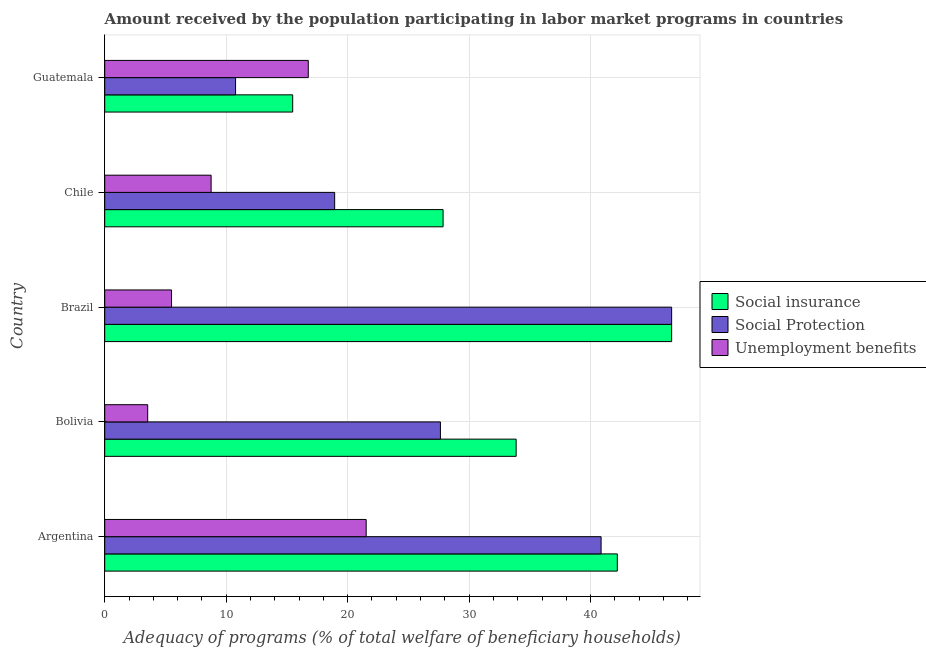How many different coloured bars are there?
Give a very brief answer. 3. Are the number of bars on each tick of the Y-axis equal?
Offer a very short reply. Yes. How many bars are there on the 5th tick from the top?
Give a very brief answer. 3. What is the label of the 4th group of bars from the top?
Provide a short and direct response. Bolivia. What is the amount received by the population participating in social insurance programs in Brazil?
Your answer should be very brief. 46.67. Across all countries, what is the maximum amount received by the population participating in social protection programs?
Offer a terse response. 46.67. Across all countries, what is the minimum amount received by the population participating in unemployment benefits programs?
Your response must be concise. 3.54. In which country was the amount received by the population participating in social protection programs minimum?
Provide a short and direct response. Guatemala. What is the total amount received by the population participating in social insurance programs in the graph?
Make the answer very short. 166.06. What is the difference between the amount received by the population participating in social insurance programs in Brazil and that in Chile?
Keep it short and to the point. 18.81. What is the difference between the amount received by the population participating in social insurance programs in Argentina and the amount received by the population participating in unemployment benefits programs in Bolivia?
Your answer should be compact. 38.66. What is the average amount received by the population participating in social insurance programs per country?
Ensure brevity in your answer.  33.21. What is the difference between the amount received by the population participating in social protection programs and amount received by the population participating in social insurance programs in Bolivia?
Give a very brief answer. -6.23. What is the ratio of the amount received by the population participating in unemployment benefits programs in Argentina to that in Chile?
Your answer should be compact. 2.46. Is the amount received by the population participating in social protection programs in Bolivia less than that in Guatemala?
Provide a short and direct response. No. Is the difference between the amount received by the population participating in social insurance programs in Bolivia and Brazil greater than the difference between the amount received by the population participating in unemployment benefits programs in Bolivia and Brazil?
Keep it short and to the point. No. What is the difference between the highest and the second highest amount received by the population participating in social protection programs?
Offer a terse response. 5.81. What is the difference between the highest and the lowest amount received by the population participating in social protection programs?
Offer a terse response. 35.9. In how many countries, is the amount received by the population participating in social insurance programs greater than the average amount received by the population participating in social insurance programs taken over all countries?
Provide a short and direct response. 3. Is the sum of the amount received by the population participating in social insurance programs in Argentina and Bolivia greater than the maximum amount received by the population participating in unemployment benefits programs across all countries?
Keep it short and to the point. Yes. What does the 2nd bar from the top in Chile represents?
Your response must be concise. Social Protection. What does the 2nd bar from the bottom in Bolivia represents?
Your answer should be very brief. Social Protection. Is it the case that in every country, the sum of the amount received by the population participating in social insurance programs and amount received by the population participating in social protection programs is greater than the amount received by the population participating in unemployment benefits programs?
Offer a terse response. Yes. What is the difference between two consecutive major ticks on the X-axis?
Your answer should be very brief. 10. Are the values on the major ticks of X-axis written in scientific E-notation?
Make the answer very short. No. How many legend labels are there?
Your answer should be very brief. 3. How are the legend labels stacked?
Give a very brief answer. Vertical. What is the title of the graph?
Provide a short and direct response. Amount received by the population participating in labor market programs in countries. What is the label or title of the X-axis?
Provide a succinct answer. Adequacy of programs (% of total welfare of beneficiary households). What is the Adequacy of programs (% of total welfare of beneficiary households) of Social insurance in Argentina?
Your response must be concise. 42.2. What is the Adequacy of programs (% of total welfare of beneficiary households) in Social Protection in Argentina?
Provide a short and direct response. 40.86. What is the Adequacy of programs (% of total welfare of beneficiary households) of Unemployment benefits in Argentina?
Offer a terse response. 21.52. What is the Adequacy of programs (% of total welfare of beneficiary households) of Social insurance in Bolivia?
Your answer should be compact. 33.87. What is the Adequacy of programs (% of total welfare of beneficiary households) in Social Protection in Bolivia?
Ensure brevity in your answer.  27.63. What is the Adequacy of programs (% of total welfare of beneficiary households) of Unemployment benefits in Bolivia?
Offer a terse response. 3.54. What is the Adequacy of programs (% of total welfare of beneficiary households) in Social insurance in Brazil?
Provide a succinct answer. 46.67. What is the Adequacy of programs (% of total welfare of beneficiary households) of Social Protection in Brazil?
Offer a very short reply. 46.67. What is the Adequacy of programs (% of total welfare of beneficiary households) of Unemployment benefits in Brazil?
Your answer should be compact. 5.5. What is the Adequacy of programs (% of total welfare of beneficiary households) in Social insurance in Chile?
Offer a terse response. 27.85. What is the Adequacy of programs (% of total welfare of beneficiary households) in Social Protection in Chile?
Provide a short and direct response. 18.93. What is the Adequacy of programs (% of total welfare of beneficiary households) of Unemployment benefits in Chile?
Make the answer very short. 8.76. What is the Adequacy of programs (% of total welfare of beneficiary households) in Social insurance in Guatemala?
Give a very brief answer. 15.47. What is the Adequacy of programs (% of total welfare of beneficiary households) of Social Protection in Guatemala?
Your response must be concise. 10.77. What is the Adequacy of programs (% of total welfare of beneficiary households) of Unemployment benefits in Guatemala?
Your response must be concise. 16.76. Across all countries, what is the maximum Adequacy of programs (% of total welfare of beneficiary households) of Social insurance?
Your answer should be very brief. 46.67. Across all countries, what is the maximum Adequacy of programs (% of total welfare of beneficiary households) in Social Protection?
Your response must be concise. 46.67. Across all countries, what is the maximum Adequacy of programs (% of total welfare of beneficiary households) of Unemployment benefits?
Keep it short and to the point. 21.52. Across all countries, what is the minimum Adequacy of programs (% of total welfare of beneficiary households) in Social insurance?
Ensure brevity in your answer.  15.47. Across all countries, what is the minimum Adequacy of programs (% of total welfare of beneficiary households) of Social Protection?
Your answer should be very brief. 10.77. Across all countries, what is the minimum Adequacy of programs (% of total welfare of beneficiary households) in Unemployment benefits?
Keep it short and to the point. 3.54. What is the total Adequacy of programs (% of total welfare of beneficiary households) of Social insurance in the graph?
Offer a very short reply. 166.06. What is the total Adequacy of programs (% of total welfare of beneficiary households) in Social Protection in the graph?
Your response must be concise. 144.86. What is the total Adequacy of programs (% of total welfare of beneficiary households) of Unemployment benefits in the graph?
Offer a terse response. 56.07. What is the difference between the Adequacy of programs (% of total welfare of beneficiary households) in Social insurance in Argentina and that in Bolivia?
Offer a very short reply. 8.33. What is the difference between the Adequacy of programs (% of total welfare of beneficiary households) in Social Protection in Argentina and that in Bolivia?
Your response must be concise. 13.23. What is the difference between the Adequacy of programs (% of total welfare of beneficiary households) of Unemployment benefits in Argentina and that in Bolivia?
Ensure brevity in your answer.  17.98. What is the difference between the Adequacy of programs (% of total welfare of beneficiary households) in Social insurance in Argentina and that in Brazil?
Keep it short and to the point. -4.47. What is the difference between the Adequacy of programs (% of total welfare of beneficiary households) in Social Protection in Argentina and that in Brazil?
Keep it short and to the point. -5.81. What is the difference between the Adequacy of programs (% of total welfare of beneficiary households) in Unemployment benefits in Argentina and that in Brazil?
Ensure brevity in your answer.  16.02. What is the difference between the Adequacy of programs (% of total welfare of beneficiary households) of Social insurance in Argentina and that in Chile?
Your answer should be very brief. 14.34. What is the difference between the Adequacy of programs (% of total welfare of beneficiary households) in Social Protection in Argentina and that in Chile?
Your answer should be compact. 21.93. What is the difference between the Adequacy of programs (% of total welfare of beneficiary households) in Unemployment benefits in Argentina and that in Chile?
Ensure brevity in your answer.  12.76. What is the difference between the Adequacy of programs (% of total welfare of beneficiary households) in Social insurance in Argentina and that in Guatemala?
Offer a terse response. 26.72. What is the difference between the Adequacy of programs (% of total welfare of beneficiary households) of Social Protection in Argentina and that in Guatemala?
Offer a terse response. 30.09. What is the difference between the Adequacy of programs (% of total welfare of beneficiary households) of Unemployment benefits in Argentina and that in Guatemala?
Your answer should be very brief. 4.76. What is the difference between the Adequacy of programs (% of total welfare of beneficiary households) of Social Protection in Bolivia and that in Brazil?
Your answer should be compact. -19.03. What is the difference between the Adequacy of programs (% of total welfare of beneficiary households) in Unemployment benefits in Bolivia and that in Brazil?
Give a very brief answer. -1.96. What is the difference between the Adequacy of programs (% of total welfare of beneficiary households) in Social insurance in Bolivia and that in Chile?
Keep it short and to the point. 6.01. What is the difference between the Adequacy of programs (% of total welfare of beneficiary households) of Social Protection in Bolivia and that in Chile?
Offer a very short reply. 8.71. What is the difference between the Adequacy of programs (% of total welfare of beneficiary households) in Unemployment benefits in Bolivia and that in Chile?
Your answer should be compact. -5.22. What is the difference between the Adequacy of programs (% of total welfare of beneficiary households) in Social insurance in Bolivia and that in Guatemala?
Your answer should be compact. 18.39. What is the difference between the Adequacy of programs (% of total welfare of beneficiary households) in Social Protection in Bolivia and that in Guatemala?
Your answer should be very brief. 16.86. What is the difference between the Adequacy of programs (% of total welfare of beneficiary households) of Unemployment benefits in Bolivia and that in Guatemala?
Ensure brevity in your answer.  -13.22. What is the difference between the Adequacy of programs (% of total welfare of beneficiary households) of Social insurance in Brazil and that in Chile?
Your answer should be very brief. 18.81. What is the difference between the Adequacy of programs (% of total welfare of beneficiary households) in Social Protection in Brazil and that in Chile?
Make the answer very short. 27.74. What is the difference between the Adequacy of programs (% of total welfare of beneficiary households) of Unemployment benefits in Brazil and that in Chile?
Provide a short and direct response. -3.26. What is the difference between the Adequacy of programs (% of total welfare of beneficiary households) of Social insurance in Brazil and that in Guatemala?
Give a very brief answer. 31.19. What is the difference between the Adequacy of programs (% of total welfare of beneficiary households) of Social Protection in Brazil and that in Guatemala?
Make the answer very short. 35.9. What is the difference between the Adequacy of programs (% of total welfare of beneficiary households) in Unemployment benefits in Brazil and that in Guatemala?
Keep it short and to the point. -11.26. What is the difference between the Adequacy of programs (% of total welfare of beneficiary households) in Social insurance in Chile and that in Guatemala?
Your answer should be compact. 12.38. What is the difference between the Adequacy of programs (% of total welfare of beneficiary households) of Social Protection in Chile and that in Guatemala?
Ensure brevity in your answer.  8.16. What is the difference between the Adequacy of programs (% of total welfare of beneficiary households) in Unemployment benefits in Chile and that in Guatemala?
Offer a very short reply. -8. What is the difference between the Adequacy of programs (% of total welfare of beneficiary households) in Social insurance in Argentina and the Adequacy of programs (% of total welfare of beneficiary households) in Social Protection in Bolivia?
Give a very brief answer. 14.56. What is the difference between the Adequacy of programs (% of total welfare of beneficiary households) in Social insurance in Argentina and the Adequacy of programs (% of total welfare of beneficiary households) in Unemployment benefits in Bolivia?
Provide a succinct answer. 38.66. What is the difference between the Adequacy of programs (% of total welfare of beneficiary households) in Social Protection in Argentina and the Adequacy of programs (% of total welfare of beneficiary households) in Unemployment benefits in Bolivia?
Make the answer very short. 37.32. What is the difference between the Adequacy of programs (% of total welfare of beneficiary households) in Social insurance in Argentina and the Adequacy of programs (% of total welfare of beneficiary households) in Social Protection in Brazil?
Ensure brevity in your answer.  -4.47. What is the difference between the Adequacy of programs (% of total welfare of beneficiary households) in Social insurance in Argentina and the Adequacy of programs (% of total welfare of beneficiary households) in Unemployment benefits in Brazil?
Provide a short and direct response. 36.69. What is the difference between the Adequacy of programs (% of total welfare of beneficiary households) of Social Protection in Argentina and the Adequacy of programs (% of total welfare of beneficiary households) of Unemployment benefits in Brazil?
Keep it short and to the point. 35.36. What is the difference between the Adequacy of programs (% of total welfare of beneficiary households) of Social insurance in Argentina and the Adequacy of programs (% of total welfare of beneficiary households) of Social Protection in Chile?
Your response must be concise. 23.27. What is the difference between the Adequacy of programs (% of total welfare of beneficiary households) in Social insurance in Argentina and the Adequacy of programs (% of total welfare of beneficiary households) in Unemployment benefits in Chile?
Offer a terse response. 33.44. What is the difference between the Adequacy of programs (% of total welfare of beneficiary households) of Social Protection in Argentina and the Adequacy of programs (% of total welfare of beneficiary households) of Unemployment benefits in Chile?
Your response must be concise. 32.1. What is the difference between the Adequacy of programs (% of total welfare of beneficiary households) in Social insurance in Argentina and the Adequacy of programs (% of total welfare of beneficiary households) in Social Protection in Guatemala?
Provide a short and direct response. 31.42. What is the difference between the Adequacy of programs (% of total welfare of beneficiary households) in Social insurance in Argentina and the Adequacy of programs (% of total welfare of beneficiary households) in Unemployment benefits in Guatemala?
Offer a terse response. 25.44. What is the difference between the Adequacy of programs (% of total welfare of beneficiary households) in Social Protection in Argentina and the Adequacy of programs (% of total welfare of beneficiary households) in Unemployment benefits in Guatemala?
Provide a short and direct response. 24.1. What is the difference between the Adequacy of programs (% of total welfare of beneficiary households) in Social insurance in Bolivia and the Adequacy of programs (% of total welfare of beneficiary households) in Unemployment benefits in Brazil?
Offer a terse response. 28.37. What is the difference between the Adequacy of programs (% of total welfare of beneficiary households) of Social Protection in Bolivia and the Adequacy of programs (% of total welfare of beneficiary households) of Unemployment benefits in Brazil?
Offer a very short reply. 22.13. What is the difference between the Adequacy of programs (% of total welfare of beneficiary households) in Social insurance in Bolivia and the Adequacy of programs (% of total welfare of beneficiary households) in Social Protection in Chile?
Make the answer very short. 14.94. What is the difference between the Adequacy of programs (% of total welfare of beneficiary households) in Social insurance in Bolivia and the Adequacy of programs (% of total welfare of beneficiary households) in Unemployment benefits in Chile?
Offer a very short reply. 25.11. What is the difference between the Adequacy of programs (% of total welfare of beneficiary households) in Social Protection in Bolivia and the Adequacy of programs (% of total welfare of beneficiary households) in Unemployment benefits in Chile?
Give a very brief answer. 18.88. What is the difference between the Adequacy of programs (% of total welfare of beneficiary households) in Social insurance in Bolivia and the Adequacy of programs (% of total welfare of beneficiary households) in Social Protection in Guatemala?
Offer a very short reply. 23.1. What is the difference between the Adequacy of programs (% of total welfare of beneficiary households) of Social insurance in Bolivia and the Adequacy of programs (% of total welfare of beneficiary households) of Unemployment benefits in Guatemala?
Provide a short and direct response. 17.11. What is the difference between the Adequacy of programs (% of total welfare of beneficiary households) of Social Protection in Bolivia and the Adequacy of programs (% of total welfare of beneficiary households) of Unemployment benefits in Guatemala?
Your answer should be very brief. 10.88. What is the difference between the Adequacy of programs (% of total welfare of beneficiary households) in Social insurance in Brazil and the Adequacy of programs (% of total welfare of beneficiary households) in Social Protection in Chile?
Your answer should be compact. 27.74. What is the difference between the Adequacy of programs (% of total welfare of beneficiary households) in Social insurance in Brazil and the Adequacy of programs (% of total welfare of beneficiary households) in Unemployment benefits in Chile?
Offer a very short reply. 37.91. What is the difference between the Adequacy of programs (% of total welfare of beneficiary households) in Social Protection in Brazil and the Adequacy of programs (% of total welfare of beneficiary households) in Unemployment benefits in Chile?
Offer a very short reply. 37.91. What is the difference between the Adequacy of programs (% of total welfare of beneficiary households) in Social insurance in Brazil and the Adequacy of programs (% of total welfare of beneficiary households) in Social Protection in Guatemala?
Provide a succinct answer. 35.9. What is the difference between the Adequacy of programs (% of total welfare of beneficiary households) in Social insurance in Brazil and the Adequacy of programs (% of total welfare of beneficiary households) in Unemployment benefits in Guatemala?
Your answer should be very brief. 29.91. What is the difference between the Adequacy of programs (% of total welfare of beneficiary households) in Social Protection in Brazil and the Adequacy of programs (% of total welfare of beneficiary households) in Unemployment benefits in Guatemala?
Make the answer very short. 29.91. What is the difference between the Adequacy of programs (% of total welfare of beneficiary households) of Social insurance in Chile and the Adequacy of programs (% of total welfare of beneficiary households) of Social Protection in Guatemala?
Provide a succinct answer. 17.08. What is the difference between the Adequacy of programs (% of total welfare of beneficiary households) of Social insurance in Chile and the Adequacy of programs (% of total welfare of beneficiary households) of Unemployment benefits in Guatemala?
Give a very brief answer. 11.1. What is the difference between the Adequacy of programs (% of total welfare of beneficiary households) in Social Protection in Chile and the Adequacy of programs (% of total welfare of beneficiary households) in Unemployment benefits in Guatemala?
Your answer should be compact. 2.17. What is the average Adequacy of programs (% of total welfare of beneficiary households) in Social insurance per country?
Your response must be concise. 33.21. What is the average Adequacy of programs (% of total welfare of beneficiary households) in Social Protection per country?
Your response must be concise. 28.97. What is the average Adequacy of programs (% of total welfare of beneficiary households) of Unemployment benefits per country?
Offer a terse response. 11.21. What is the difference between the Adequacy of programs (% of total welfare of beneficiary households) of Social insurance and Adequacy of programs (% of total welfare of beneficiary households) of Social Protection in Argentina?
Your answer should be compact. 1.33. What is the difference between the Adequacy of programs (% of total welfare of beneficiary households) in Social insurance and Adequacy of programs (% of total welfare of beneficiary households) in Unemployment benefits in Argentina?
Provide a succinct answer. 20.67. What is the difference between the Adequacy of programs (% of total welfare of beneficiary households) of Social Protection and Adequacy of programs (% of total welfare of beneficiary households) of Unemployment benefits in Argentina?
Your response must be concise. 19.34. What is the difference between the Adequacy of programs (% of total welfare of beneficiary households) in Social insurance and Adequacy of programs (% of total welfare of beneficiary households) in Social Protection in Bolivia?
Your answer should be compact. 6.23. What is the difference between the Adequacy of programs (% of total welfare of beneficiary households) in Social insurance and Adequacy of programs (% of total welfare of beneficiary households) in Unemployment benefits in Bolivia?
Ensure brevity in your answer.  30.33. What is the difference between the Adequacy of programs (% of total welfare of beneficiary households) of Social Protection and Adequacy of programs (% of total welfare of beneficiary households) of Unemployment benefits in Bolivia?
Your answer should be very brief. 24.1. What is the difference between the Adequacy of programs (% of total welfare of beneficiary households) in Social insurance and Adequacy of programs (% of total welfare of beneficiary households) in Social Protection in Brazil?
Give a very brief answer. 0. What is the difference between the Adequacy of programs (% of total welfare of beneficiary households) of Social insurance and Adequacy of programs (% of total welfare of beneficiary households) of Unemployment benefits in Brazil?
Keep it short and to the point. 41.17. What is the difference between the Adequacy of programs (% of total welfare of beneficiary households) of Social Protection and Adequacy of programs (% of total welfare of beneficiary households) of Unemployment benefits in Brazil?
Your response must be concise. 41.17. What is the difference between the Adequacy of programs (% of total welfare of beneficiary households) of Social insurance and Adequacy of programs (% of total welfare of beneficiary households) of Social Protection in Chile?
Your answer should be very brief. 8.93. What is the difference between the Adequacy of programs (% of total welfare of beneficiary households) in Social insurance and Adequacy of programs (% of total welfare of beneficiary households) in Unemployment benefits in Chile?
Give a very brief answer. 19.1. What is the difference between the Adequacy of programs (% of total welfare of beneficiary households) of Social Protection and Adequacy of programs (% of total welfare of beneficiary households) of Unemployment benefits in Chile?
Your response must be concise. 10.17. What is the difference between the Adequacy of programs (% of total welfare of beneficiary households) of Social insurance and Adequacy of programs (% of total welfare of beneficiary households) of Social Protection in Guatemala?
Provide a short and direct response. 4.7. What is the difference between the Adequacy of programs (% of total welfare of beneficiary households) in Social insurance and Adequacy of programs (% of total welfare of beneficiary households) in Unemployment benefits in Guatemala?
Provide a short and direct response. -1.28. What is the difference between the Adequacy of programs (% of total welfare of beneficiary households) of Social Protection and Adequacy of programs (% of total welfare of beneficiary households) of Unemployment benefits in Guatemala?
Offer a terse response. -5.99. What is the ratio of the Adequacy of programs (% of total welfare of beneficiary households) of Social insurance in Argentina to that in Bolivia?
Make the answer very short. 1.25. What is the ratio of the Adequacy of programs (% of total welfare of beneficiary households) in Social Protection in Argentina to that in Bolivia?
Offer a very short reply. 1.48. What is the ratio of the Adequacy of programs (% of total welfare of beneficiary households) of Unemployment benefits in Argentina to that in Bolivia?
Give a very brief answer. 6.08. What is the ratio of the Adequacy of programs (% of total welfare of beneficiary households) of Social insurance in Argentina to that in Brazil?
Keep it short and to the point. 0.9. What is the ratio of the Adequacy of programs (% of total welfare of beneficiary households) in Social Protection in Argentina to that in Brazil?
Ensure brevity in your answer.  0.88. What is the ratio of the Adequacy of programs (% of total welfare of beneficiary households) of Unemployment benefits in Argentina to that in Brazil?
Keep it short and to the point. 3.91. What is the ratio of the Adequacy of programs (% of total welfare of beneficiary households) of Social insurance in Argentina to that in Chile?
Give a very brief answer. 1.51. What is the ratio of the Adequacy of programs (% of total welfare of beneficiary households) in Social Protection in Argentina to that in Chile?
Offer a terse response. 2.16. What is the ratio of the Adequacy of programs (% of total welfare of beneficiary households) in Unemployment benefits in Argentina to that in Chile?
Ensure brevity in your answer.  2.46. What is the ratio of the Adequacy of programs (% of total welfare of beneficiary households) in Social insurance in Argentina to that in Guatemala?
Offer a very short reply. 2.73. What is the ratio of the Adequacy of programs (% of total welfare of beneficiary households) of Social Protection in Argentina to that in Guatemala?
Provide a succinct answer. 3.79. What is the ratio of the Adequacy of programs (% of total welfare of beneficiary households) in Unemployment benefits in Argentina to that in Guatemala?
Make the answer very short. 1.28. What is the ratio of the Adequacy of programs (% of total welfare of beneficiary households) of Social insurance in Bolivia to that in Brazil?
Your answer should be compact. 0.73. What is the ratio of the Adequacy of programs (% of total welfare of beneficiary households) of Social Protection in Bolivia to that in Brazil?
Keep it short and to the point. 0.59. What is the ratio of the Adequacy of programs (% of total welfare of beneficiary households) of Unemployment benefits in Bolivia to that in Brazil?
Your answer should be very brief. 0.64. What is the ratio of the Adequacy of programs (% of total welfare of beneficiary households) in Social insurance in Bolivia to that in Chile?
Provide a succinct answer. 1.22. What is the ratio of the Adequacy of programs (% of total welfare of beneficiary households) of Social Protection in Bolivia to that in Chile?
Your answer should be very brief. 1.46. What is the ratio of the Adequacy of programs (% of total welfare of beneficiary households) of Unemployment benefits in Bolivia to that in Chile?
Ensure brevity in your answer.  0.4. What is the ratio of the Adequacy of programs (% of total welfare of beneficiary households) in Social insurance in Bolivia to that in Guatemala?
Offer a terse response. 2.19. What is the ratio of the Adequacy of programs (% of total welfare of beneficiary households) in Social Protection in Bolivia to that in Guatemala?
Ensure brevity in your answer.  2.57. What is the ratio of the Adequacy of programs (% of total welfare of beneficiary households) in Unemployment benefits in Bolivia to that in Guatemala?
Give a very brief answer. 0.21. What is the ratio of the Adequacy of programs (% of total welfare of beneficiary households) in Social insurance in Brazil to that in Chile?
Give a very brief answer. 1.68. What is the ratio of the Adequacy of programs (% of total welfare of beneficiary households) in Social Protection in Brazil to that in Chile?
Provide a short and direct response. 2.47. What is the ratio of the Adequacy of programs (% of total welfare of beneficiary households) of Unemployment benefits in Brazil to that in Chile?
Your answer should be compact. 0.63. What is the ratio of the Adequacy of programs (% of total welfare of beneficiary households) in Social insurance in Brazil to that in Guatemala?
Your response must be concise. 3.02. What is the ratio of the Adequacy of programs (% of total welfare of beneficiary households) in Social Protection in Brazil to that in Guatemala?
Keep it short and to the point. 4.33. What is the ratio of the Adequacy of programs (% of total welfare of beneficiary households) of Unemployment benefits in Brazil to that in Guatemala?
Ensure brevity in your answer.  0.33. What is the ratio of the Adequacy of programs (% of total welfare of beneficiary households) in Social insurance in Chile to that in Guatemala?
Keep it short and to the point. 1.8. What is the ratio of the Adequacy of programs (% of total welfare of beneficiary households) of Social Protection in Chile to that in Guatemala?
Keep it short and to the point. 1.76. What is the ratio of the Adequacy of programs (% of total welfare of beneficiary households) in Unemployment benefits in Chile to that in Guatemala?
Ensure brevity in your answer.  0.52. What is the difference between the highest and the second highest Adequacy of programs (% of total welfare of beneficiary households) of Social insurance?
Make the answer very short. 4.47. What is the difference between the highest and the second highest Adequacy of programs (% of total welfare of beneficiary households) in Social Protection?
Provide a short and direct response. 5.81. What is the difference between the highest and the second highest Adequacy of programs (% of total welfare of beneficiary households) in Unemployment benefits?
Your response must be concise. 4.76. What is the difference between the highest and the lowest Adequacy of programs (% of total welfare of beneficiary households) of Social insurance?
Ensure brevity in your answer.  31.19. What is the difference between the highest and the lowest Adequacy of programs (% of total welfare of beneficiary households) of Social Protection?
Provide a succinct answer. 35.9. What is the difference between the highest and the lowest Adequacy of programs (% of total welfare of beneficiary households) in Unemployment benefits?
Provide a short and direct response. 17.98. 